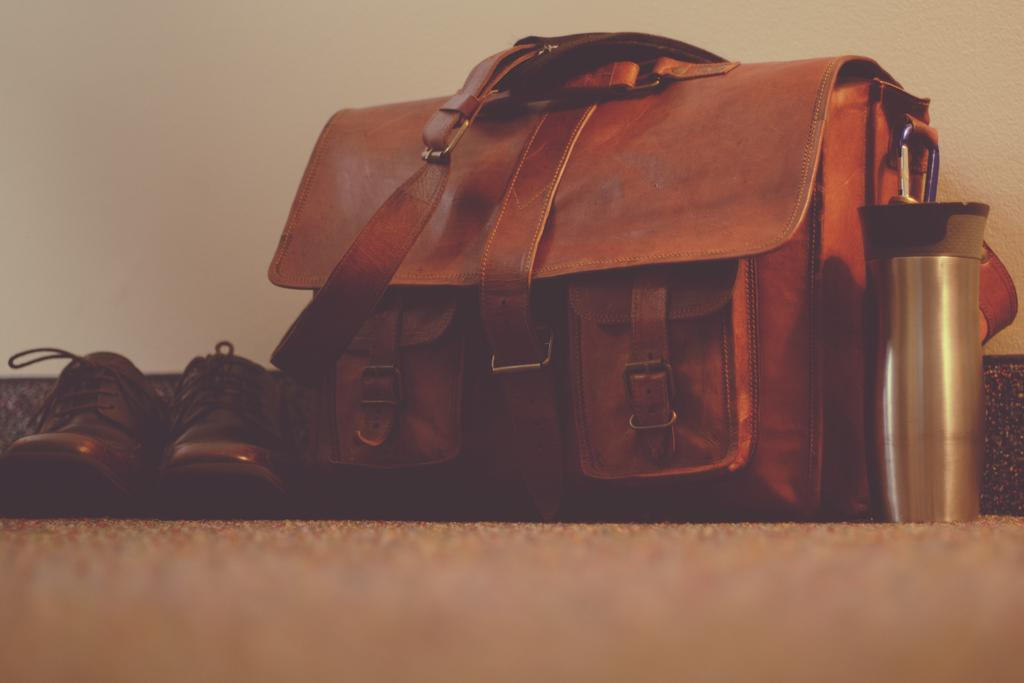What type of bag is visible in the image? There is a brown color leather bag in the image. What other items can be seen in the image? There are shoes and a bottle visible in the image. Where is the volleyball located in the image? There is no volleyball present in the image. What color is the spot on the shoes in the image? There is no mention of a spot on the shoes in the image, and the color of the shoes is not specified. 